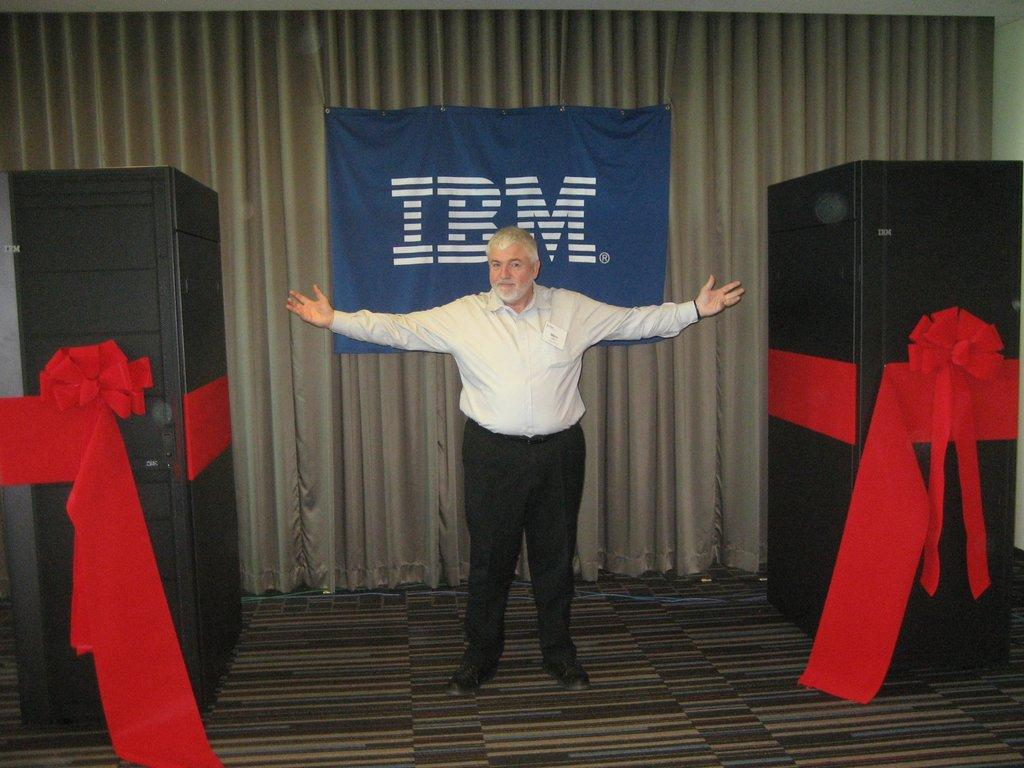What is the main subject of the image? There is a person standing in the image. What can be seen on either side of the person? There are objects on either side of the person. What company or brand is associated with the image? The text "IBM" is visible behind the person. What type of mitten is the person wearing in the image? There is no mitten visible in the image; the person is not wearing any gloves or mittens. What dish is the person cooking in the image? There is no cooking or food preparation visible in the image; the person is simply standing. 